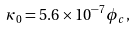Convert formula to latex. <formula><loc_0><loc_0><loc_500><loc_500>\kappa _ { 0 } = 5 . 6 \times 1 0 ^ { - 7 } \phi _ { c } ,</formula> 